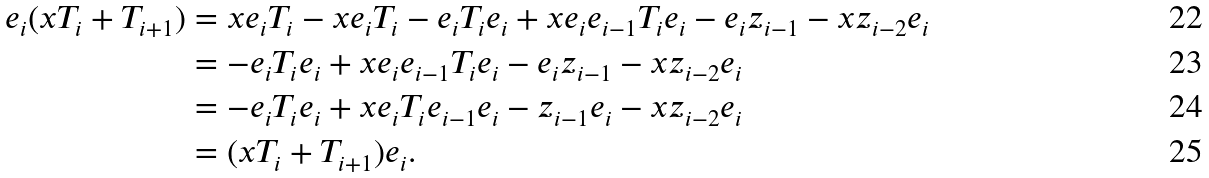Convert formula to latex. <formula><loc_0><loc_0><loc_500><loc_500>e _ { i } ( x T _ { i } + T _ { i + 1 } ) & = x e _ { i } T _ { i } - x e _ { i } T _ { i } - e _ { i } T _ { i } e _ { i } + x e _ { i } e _ { i - 1 } T _ { i } e _ { i } - e _ { i } z _ { i - 1 } - x z _ { i - 2 } e _ { i } \\ & = - e _ { i } T _ { i } e _ { i } + x e _ { i } e _ { i - 1 } T _ { i } e _ { i } - e _ { i } z _ { i - 1 } - x z _ { i - 2 } e _ { i } \\ & = - e _ { i } T _ { i } e _ { i } + x e _ { i } T _ { i } e _ { i - 1 } e _ { i } - z _ { i - 1 } e _ { i } - x z _ { i - 2 } e _ { i } \\ & = ( x T _ { i } + T _ { i + 1 } ) e _ { i } .</formula> 